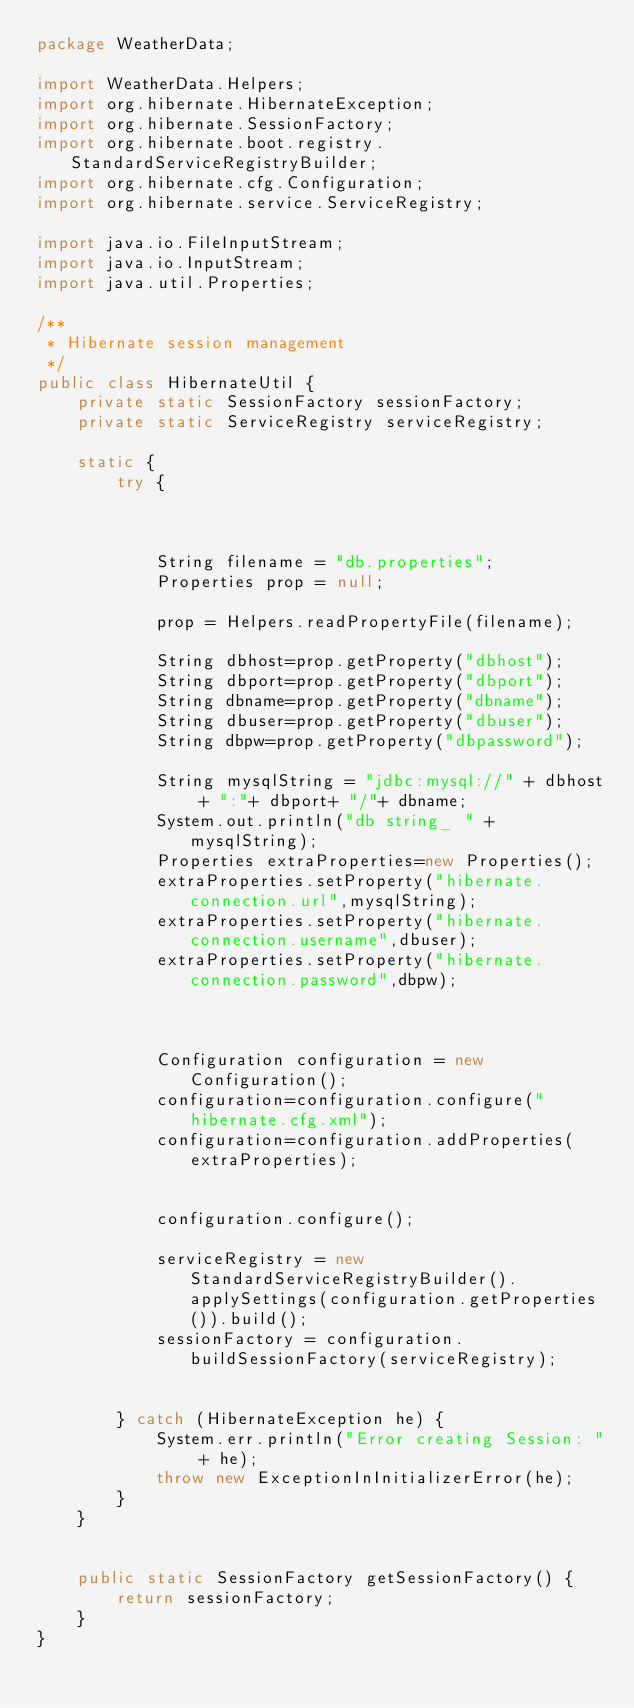Convert code to text. <code><loc_0><loc_0><loc_500><loc_500><_Java_>package WeatherData;

import WeatherData.Helpers;
import org.hibernate.HibernateException;
import org.hibernate.SessionFactory;
import org.hibernate.boot.registry.StandardServiceRegistryBuilder;
import org.hibernate.cfg.Configuration;
import org.hibernate.service.ServiceRegistry;

import java.io.FileInputStream;
import java.io.InputStream;
import java.util.Properties;

/**
 * Hibernate session management
 */
public class HibernateUtil {
    private static SessionFactory sessionFactory;
    private static ServiceRegistry serviceRegistry;

    static {
        try {



            String filename = "db.properties";
            Properties prop = null;

            prop = Helpers.readPropertyFile(filename);

            String dbhost=prop.getProperty("dbhost");
            String dbport=prop.getProperty("dbport");
            String dbname=prop.getProperty("dbname");
            String dbuser=prop.getProperty("dbuser");
            String dbpw=prop.getProperty("dbpassword");

            String mysqlString = "jdbc:mysql://" + dbhost + ":"+ dbport+ "/"+ dbname;
            System.out.println("db string_ " + mysqlString);
            Properties extraProperties=new Properties();
            extraProperties.setProperty("hibernate.connection.url",mysqlString);
            extraProperties.setProperty("hibernate.connection.username",dbuser);
            extraProperties.setProperty("hibernate.connection.password",dbpw);



            Configuration configuration = new Configuration();
            configuration=configuration.configure("hibernate.cfg.xml");
            configuration=configuration.addProperties(extraProperties);


            configuration.configure();

            serviceRegistry = new StandardServiceRegistryBuilder().applySettings(configuration.getProperties()).build();
            sessionFactory = configuration.buildSessionFactory(serviceRegistry);


        } catch (HibernateException he) {
            System.err.println("Error creating Session: " + he);
            throw new ExceptionInInitializerError(he);
        }
    }


    public static SessionFactory getSessionFactory() {
        return sessionFactory;
    }
}</code> 